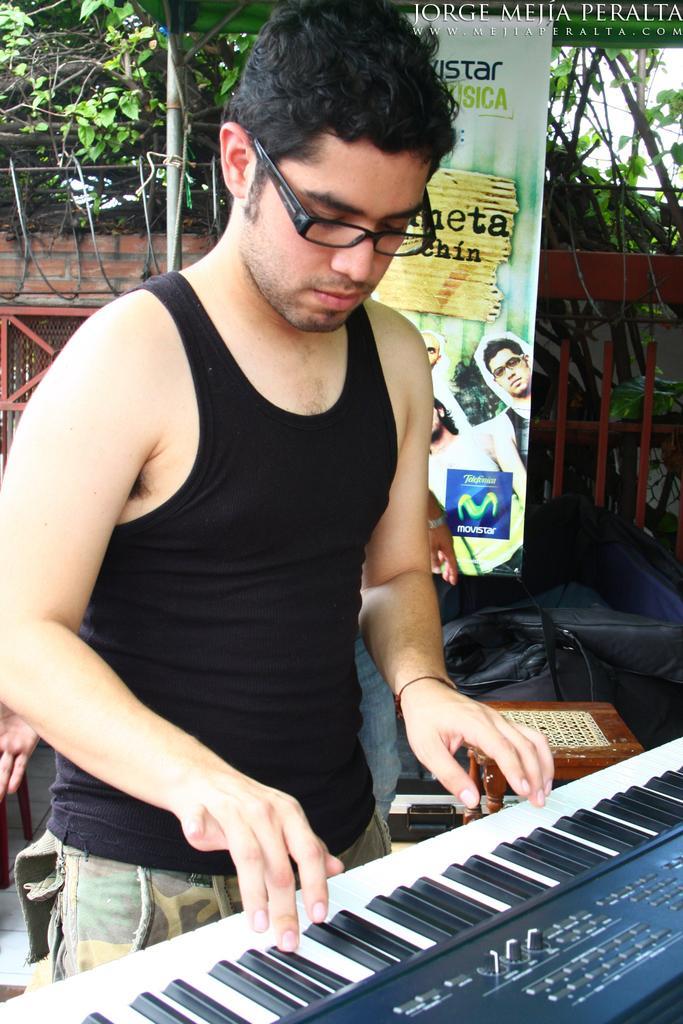Describe this image in one or two sentences. On the background we can see wall with bricks, trees. This is a banner. Here we can see one man wearing black colour spectacles, standing and playing a piano. This is a stool. This is a wall. 